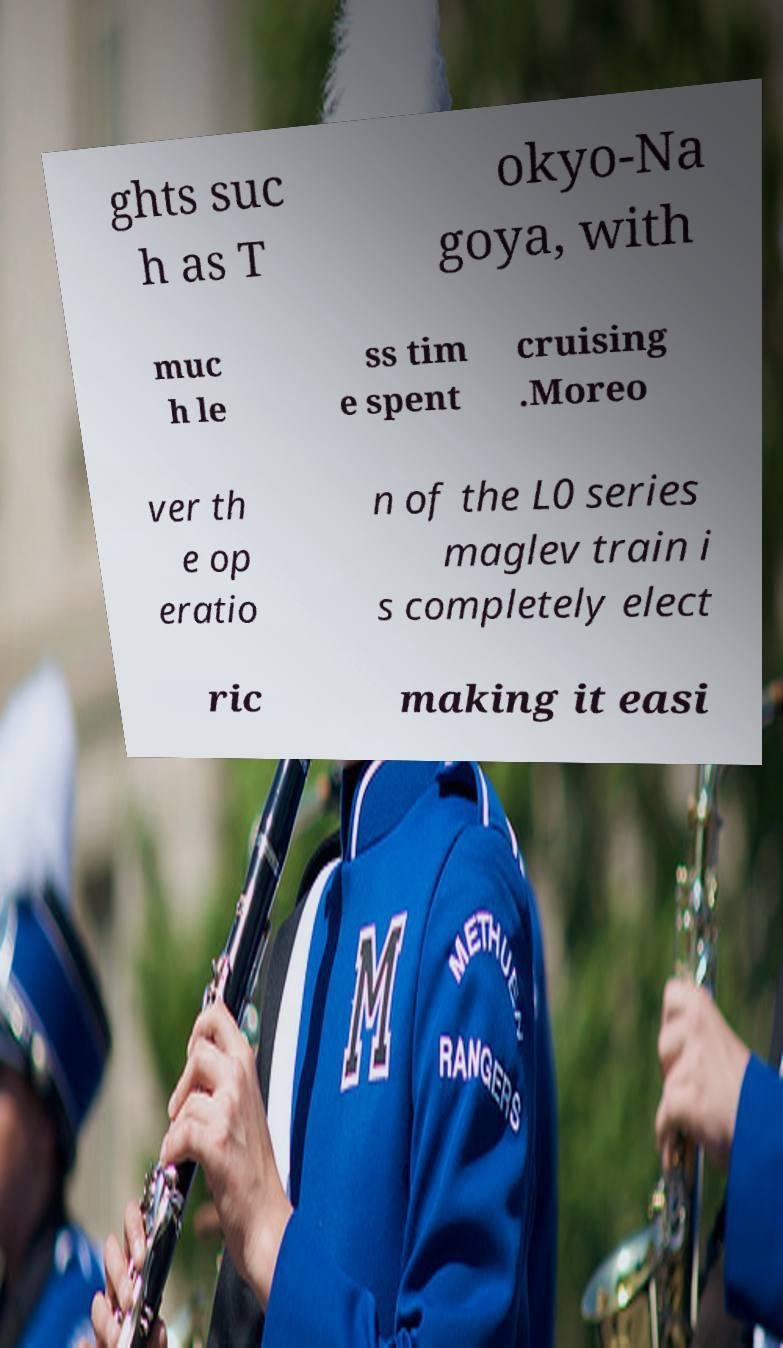There's text embedded in this image that I need extracted. Can you transcribe it verbatim? ghts suc h as T okyo-Na goya, with muc h le ss tim e spent cruising .Moreo ver th e op eratio n of the L0 series maglev train i s completely elect ric making it easi 